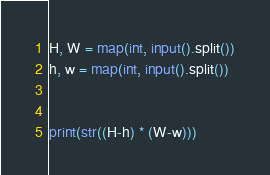Convert code to text. <code><loc_0><loc_0><loc_500><loc_500><_Python_>H, W = map(int, input().split())
h, w = map(int, input().split())


print(str((H-h) * (W-w)))



</code> 